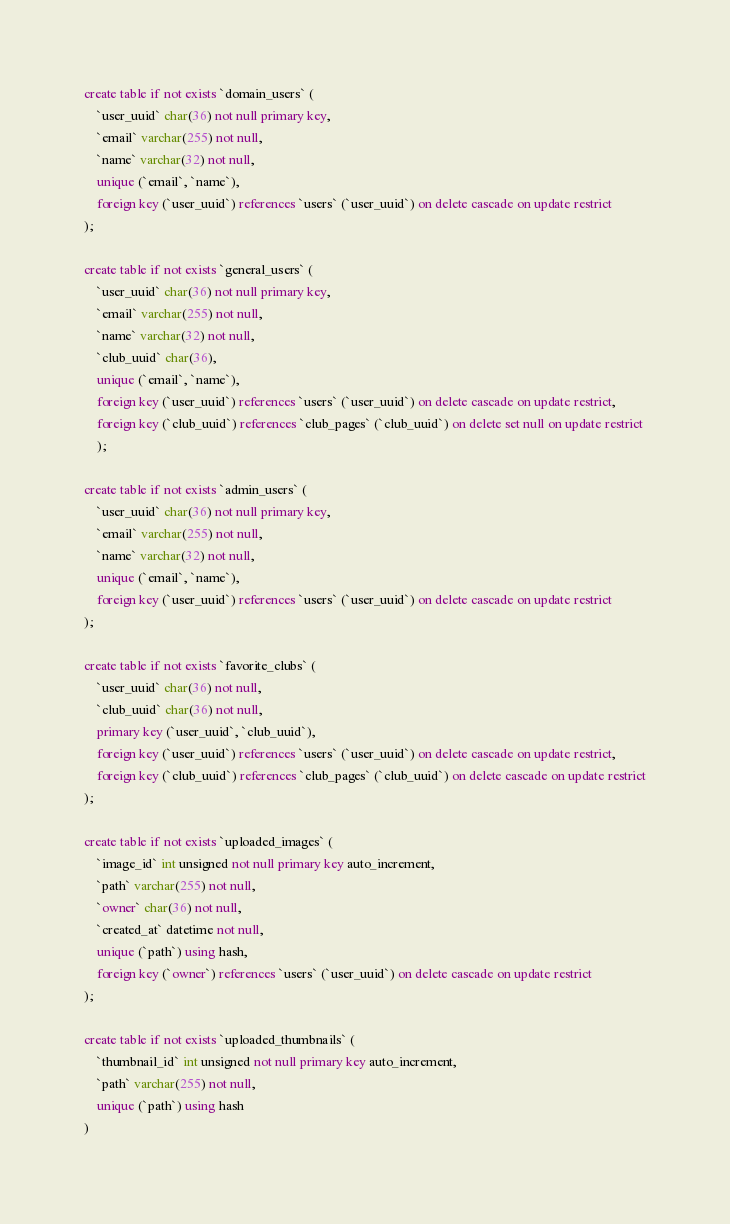Convert code to text. <code><loc_0><loc_0><loc_500><loc_500><_SQL_>create table if not exists `domain_users` (
    `user_uuid` char(36) not null primary key,
    `email` varchar(255) not null,
    `name` varchar(32) not null,
    unique (`email`, `name`),
    foreign key (`user_uuid`) references `users` (`user_uuid`) on delete cascade on update restrict
);

create table if not exists `general_users` (
    `user_uuid` char(36) not null primary key,
    `email` varchar(255) not null,
    `name` varchar(32) not null,
    `club_uuid` char(36),
    unique (`email`, `name`),
    foreign key (`user_uuid`) references `users` (`user_uuid`) on delete cascade on update restrict,
    foreign key (`club_uuid`) references `club_pages` (`club_uuid`) on delete set null on update restrict
    );

create table if not exists `admin_users` (
    `user_uuid` char(36) not null primary key,
    `email` varchar(255) not null,
    `name` varchar(32) not null,
    unique (`email`, `name`),
    foreign key (`user_uuid`) references `users` (`user_uuid`) on delete cascade on update restrict
);

create table if not exists `favorite_clubs` (
    `user_uuid` char(36) not null,
    `club_uuid` char(36) not null,
    primary key (`user_uuid`, `club_uuid`),
    foreign key (`user_uuid`) references `users` (`user_uuid`) on delete cascade on update restrict,
    foreign key (`club_uuid`) references `club_pages` (`club_uuid`) on delete cascade on update restrict
);

create table if not exists `uploaded_images` (
    `image_id` int unsigned not null primary key auto_increment,
    `path` varchar(255) not null,
    `owner` char(36) not null,
    `created_at` datetime not null,
    unique (`path`) using hash,
    foreign key (`owner`) references `users` (`user_uuid`) on delete cascade on update restrict
);

create table if not exists `uploaded_thumbnails` (
    `thumbnail_id` int unsigned not null primary key auto_increment,
    `path` varchar(255) not null,
    unique (`path`) using hash
)
</code> 